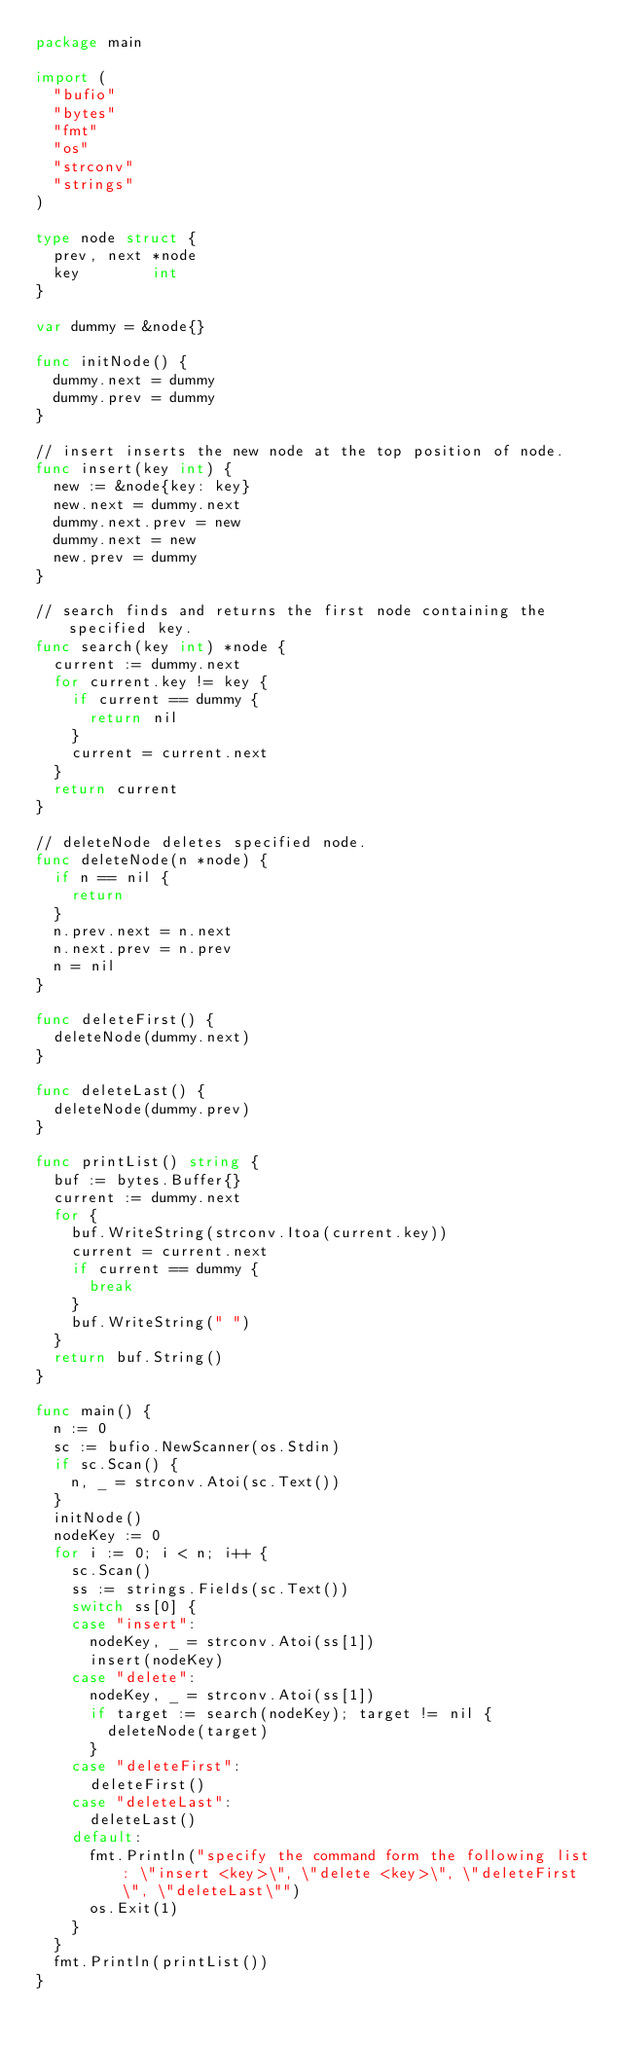<code> <loc_0><loc_0><loc_500><loc_500><_Go_>package main

import (
	"bufio"
	"bytes"
	"fmt"
	"os"
	"strconv"
	"strings"
)

type node struct {
	prev, next *node
	key        int
}

var dummy = &node{}

func initNode() {
	dummy.next = dummy
	dummy.prev = dummy
}

// insert inserts the new node at the top position of node.
func insert(key int) {
	new := &node{key: key}
	new.next = dummy.next
	dummy.next.prev = new
	dummy.next = new
	new.prev = dummy
}

// search finds and returns the first node containing the specified key.
func search(key int) *node {
	current := dummy.next
	for current.key != key {
		if current == dummy {
			return nil
		}
		current = current.next
	}
	return current
}

// deleteNode deletes specified node.
func deleteNode(n *node) {
	if n == nil {
		return
	}
	n.prev.next = n.next
	n.next.prev = n.prev
	n = nil
}

func deleteFirst() {
	deleteNode(dummy.next)
}

func deleteLast() {
	deleteNode(dummy.prev)
}

func printList() string {
	buf := bytes.Buffer{}
	current := dummy.next
	for {
		buf.WriteString(strconv.Itoa(current.key))
		current = current.next
		if current == dummy {
			break
		}
		buf.WriteString(" ")
	}
	return buf.String()
}

func main() {
	n := 0
	sc := bufio.NewScanner(os.Stdin)
	if sc.Scan() {
		n, _ = strconv.Atoi(sc.Text())
	}
	initNode()
	nodeKey := 0
	for i := 0; i < n; i++ {
		sc.Scan()
		ss := strings.Fields(sc.Text())
		switch ss[0] {
		case "insert":
			nodeKey, _ = strconv.Atoi(ss[1])
			insert(nodeKey)
		case "delete":
			nodeKey, _ = strconv.Atoi(ss[1])
			if target := search(nodeKey); target != nil {
				deleteNode(target)
			}
		case "deleteFirst":
			deleteFirst()
		case "deleteLast":
			deleteLast()
		default:
			fmt.Println("specify the command form the following list: \"insert <key>\", \"delete <key>\", \"deleteFirst\", \"deleteLast\"")
			os.Exit(1)
		}
	}
	fmt.Println(printList())
}

</code> 